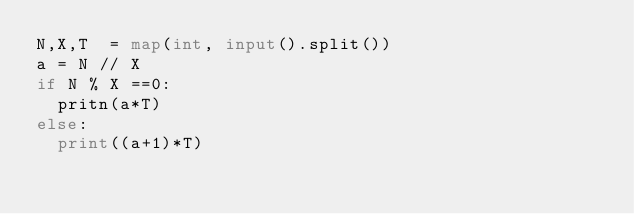Convert code to text. <code><loc_0><loc_0><loc_500><loc_500><_Python_>N,X,T  = map(int, input().split())
a = N // X
if N % X ==0:
  pritn(a*T)
else:
	print((a+1)*T)</code> 